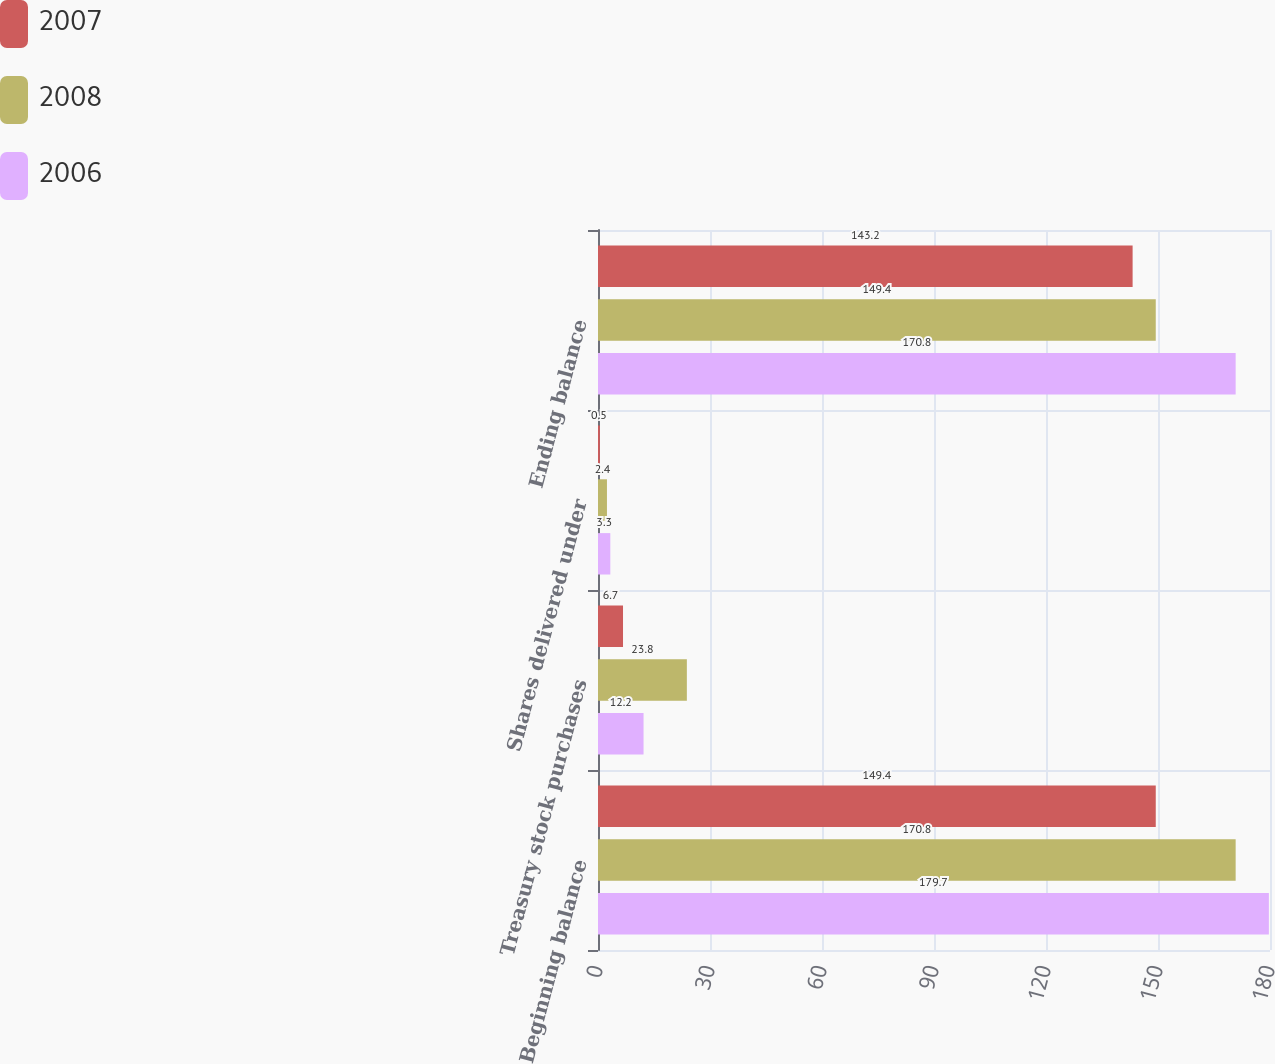Convert chart. <chart><loc_0><loc_0><loc_500><loc_500><stacked_bar_chart><ecel><fcel>Beginning balance<fcel>Treasury stock purchases<fcel>Shares delivered under<fcel>Ending balance<nl><fcel>2007<fcel>149.4<fcel>6.7<fcel>0.5<fcel>143.2<nl><fcel>2008<fcel>170.8<fcel>23.8<fcel>2.4<fcel>149.4<nl><fcel>2006<fcel>179.7<fcel>12.2<fcel>3.3<fcel>170.8<nl></chart> 